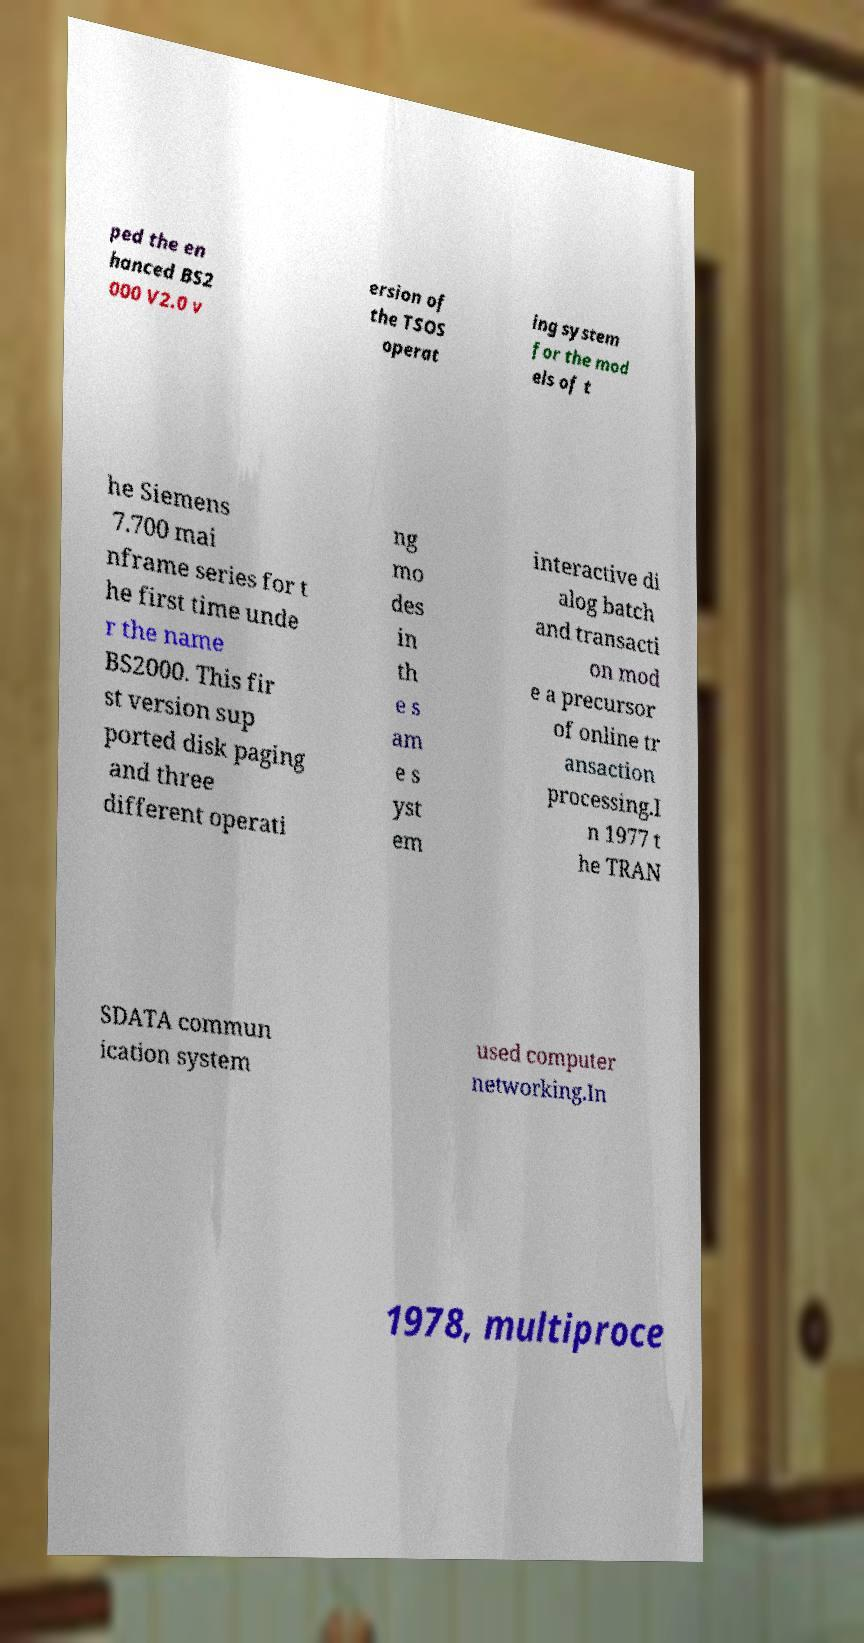There's text embedded in this image that I need extracted. Can you transcribe it verbatim? ped the en hanced BS2 000 V2.0 v ersion of the TSOS operat ing system for the mod els of t he Siemens 7.700 mai nframe series for t he first time unde r the name BS2000. This fir st version sup ported disk paging and three different operati ng mo des in th e s am e s yst em interactive di alog batch and transacti on mod e a precursor of online tr ansaction processing.I n 1977 t he TRAN SDATA commun ication system used computer networking.In 1978, multiproce 